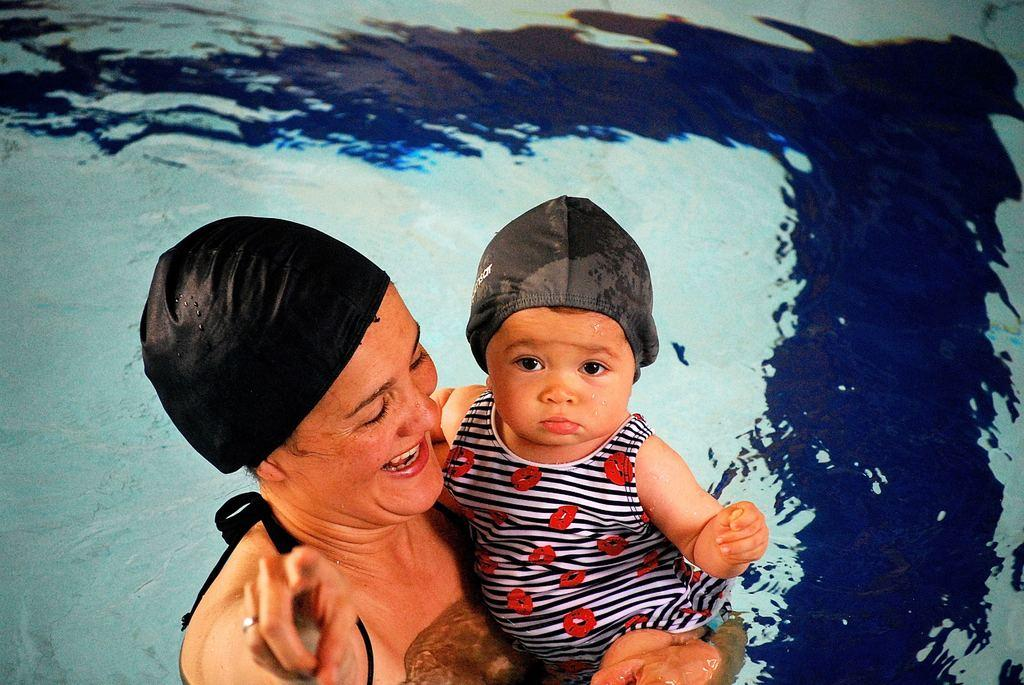Who is present in the image? There is a woman in the image. What is the woman doing in the image? The woman is smiling and carrying a baby. What can be seen in the background of the image? There is water visible in the background of the image. What type of sound can be heard coming from the library in the image? There is no library present in the image, so it's not possible to determine what, if any, sounds might be heard. 